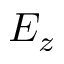Convert formula to latex. <formula><loc_0><loc_0><loc_500><loc_500>E _ { z }</formula> 